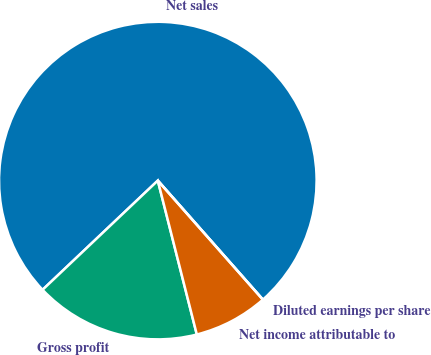Convert chart. <chart><loc_0><loc_0><loc_500><loc_500><pie_chart><fcel>Net sales<fcel>Gross profit<fcel>Net income attributable to<fcel>Diluted earnings per share<nl><fcel>75.57%<fcel>16.88%<fcel>7.56%<fcel>0.0%<nl></chart> 